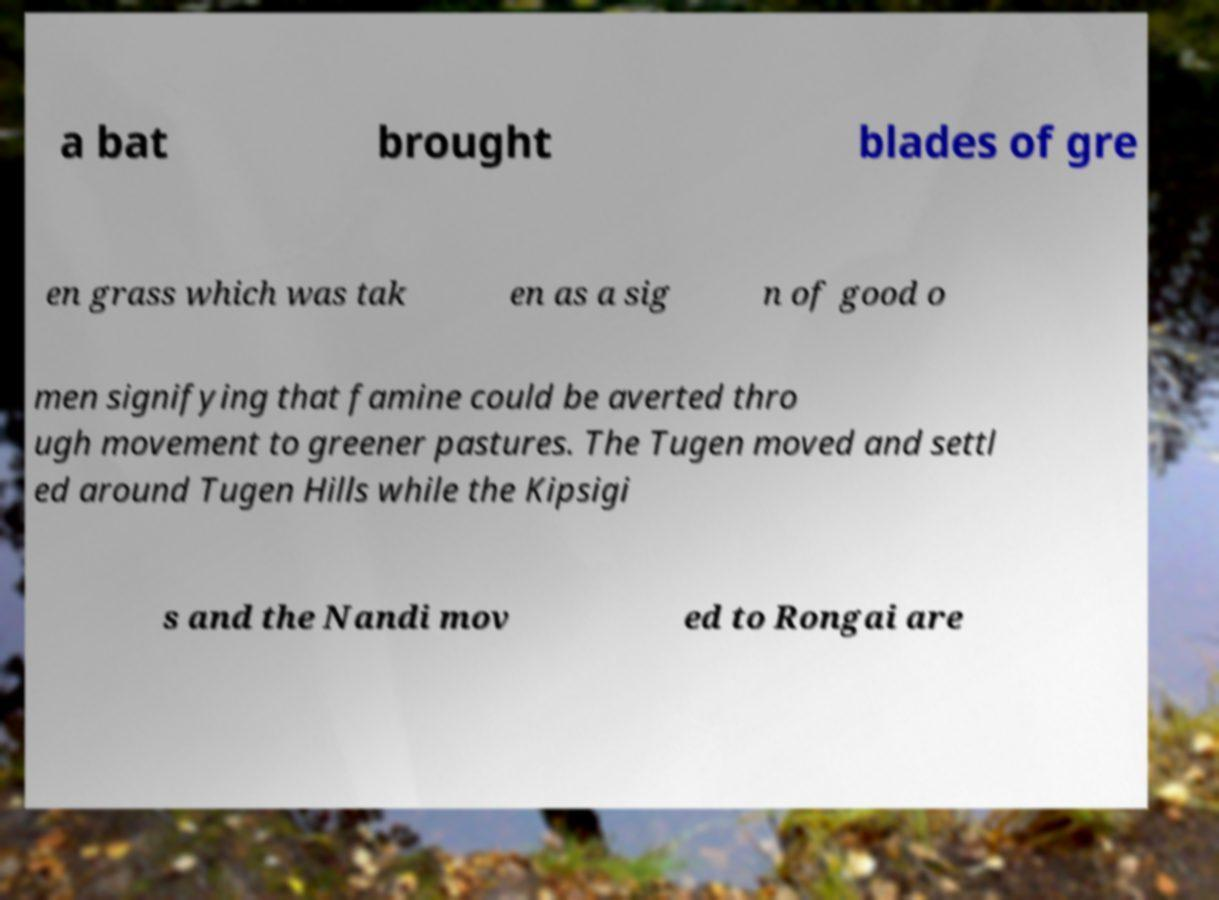For documentation purposes, I need the text within this image transcribed. Could you provide that? a bat brought blades of gre en grass which was tak en as a sig n of good o men signifying that famine could be averted thro ugh movement to greener pastures. The Tugen moved and settl ed around Tugen Hills while the Kipsigi s and the Nandi mov ed to Rongai are 